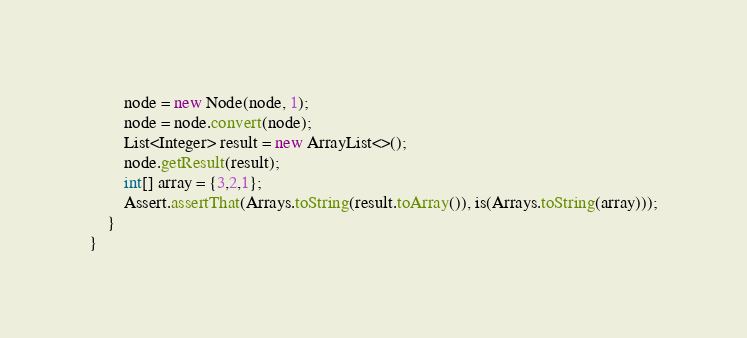<code> <loc_0><loc_0><loc_500><loc_500><_Java_>        node = new Node(node, 1);
        node = node.convert(node);
        List<Integer> result = new ArrayList<>();
        node.getResult(result);
        int[] array = {3,2,1};
        Assert.assertThat(Arrays.toString(result.toArray()), is(Arrays.toString(array)));
    }
}</code> 